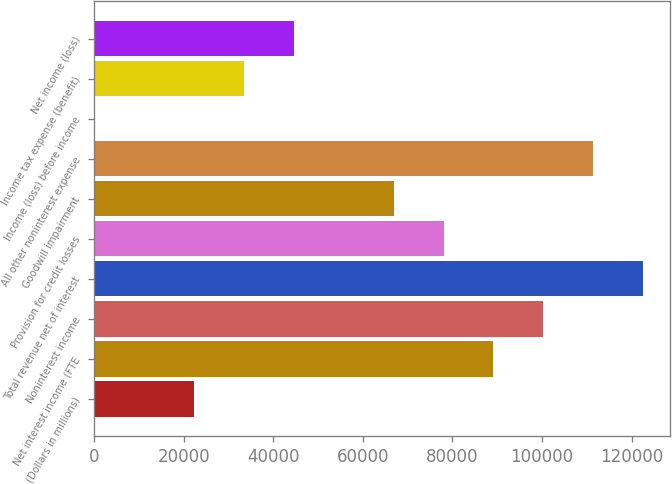<chart> <loc_0><loc_0><loc_500><loc_500><bar_chart><fcel>(Dollars in millions)<fcel>Net interest income (FTE<fcel>Noninterest income<fcel>Total revenue net of interest<fcel>Provision for credit losses<fcel>Goodwill impairment<fcel>All other noninterest expense<fcel>Income (loss) before income<fcel>Income tax expense (benefit)<fcel>Net income (loss)<nl><fcel>22400.4<fcel>89142.6<fcel>100266<fcel>122514<fcel>78018.9<fcel>66895.2<fcel>111390<fcel>153<fcel>33524.1<fcel>44647.8<nl></chart> 